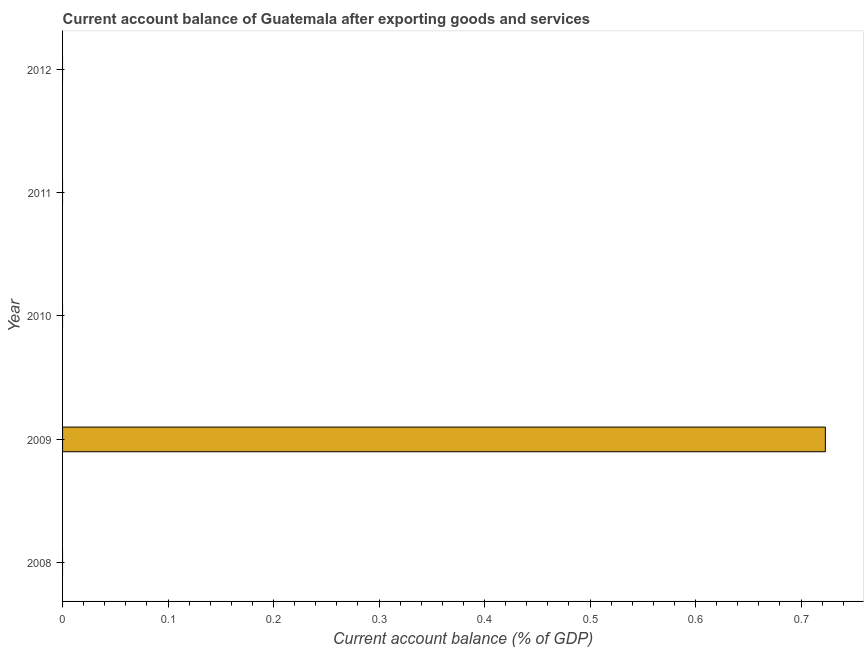Does the graph contain any zero values?
Provide a succinct answer. Yes. What is the title of the graph?
Your answer should be compact. Current account balance of Guatemala after exporting goods and services. What is the label or title of the X-axis?
Your response must be concise. Current account balance (% of GDP). Across all years, what is the maximum current account balance?
Keep it short and to the point. 0.72. In which year was the current account balance maximum?
Your answer should be compact. 2009. What is the sum of the current account balance?
Your answer should be compact. 0.72. What is the average current account balance per year?
Provide a short and direct response. 0.14. What is the median current account balance?
Give a very brief answer. 0. What is the difference between the highest and the lowest current account balance?
Your answer should be very brief. 0.72. In how many years, is the current account balance greater than the average current account balance taken over all years?
Ensure brevity in your answer.  1. How many bars are there?
Ensure brevity in your answer.  1. Are all the bars in the graph horizontal?
Provide a succinct answer. Yes. How many years are there in the graph?
Your answer should be compact. 5. Are the values on the major ticks of X-axis written in scientific E-notation?
Your answer should be compact. No. What is the Current account balance (% of GDP) of 2009?
Ensure brevity in your answer.  0.72. What is the Current account balance (% of GDP) in 2012?
Offer a terse response. 0. 